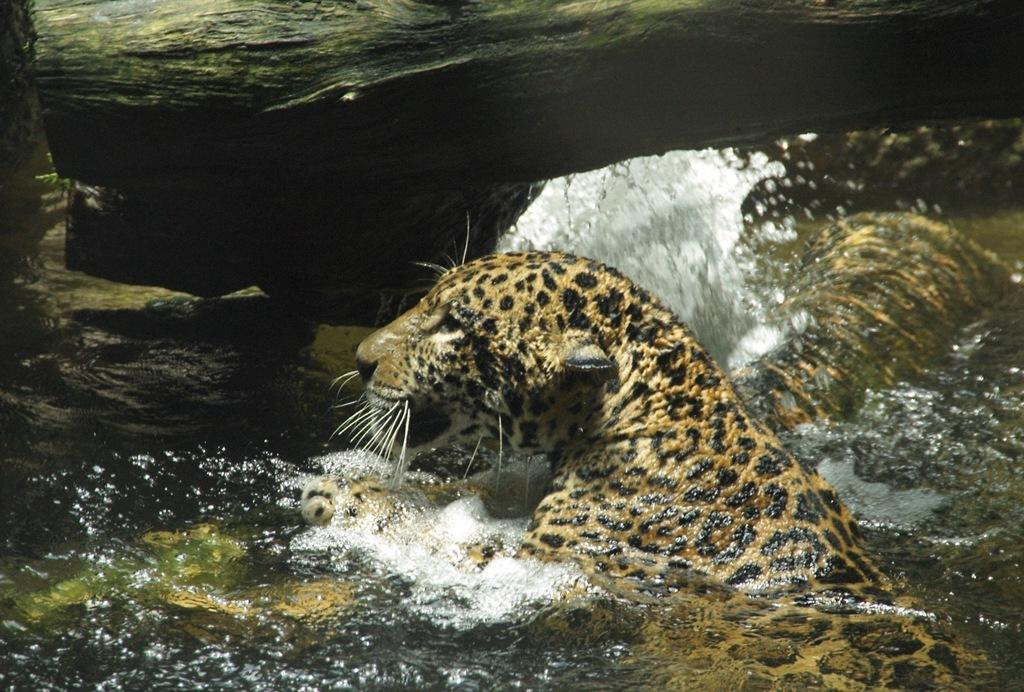What animal can be seen in the water in the image? There is a leopard in the water in the image. What else is visible in the image besides the leopard? There is a branch of a tree visible in the image. How many leopards are in the water in the image? There are two leopards in the water in the image. What shape is the mouth of the leopard in the image? The image does not show the mouth of the leopard, so it is not possible to determine its shape. 